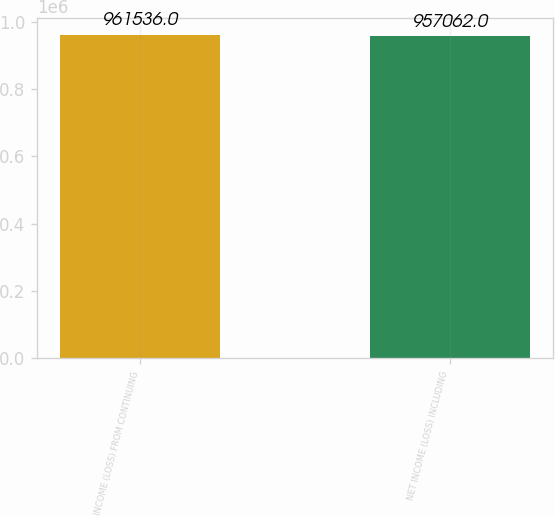<chart> <loc_0><loc_0><loc_500><loc_500><bar_chart><fcel>INCOME (LOSS) FROM CONTINUING<fcel>NET INCOME (LOSS) INCLUDING<nl><fcel>961536<fcel>957062<nl></chart> 